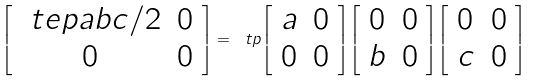<formula> <loc_0><loc_0><loc_500><loc_500>\left [ \begin{array} { c c } \ t e p { a } { b } { c } / 2 & 0 \\ 0 & 0 \end{array} \right ] = \ t p { \left [ \begin{array} { c c } a & 0 \\ 0 & 0 \end{array} \right ] } { \left [ \begin{array} { c c } 0 & 0 \\ b & 0 \end{array} \right ] } { \left [ \begin{array} { c c } 0 & 0 \\ c & 0 \end{array} \right ] }</formula> 